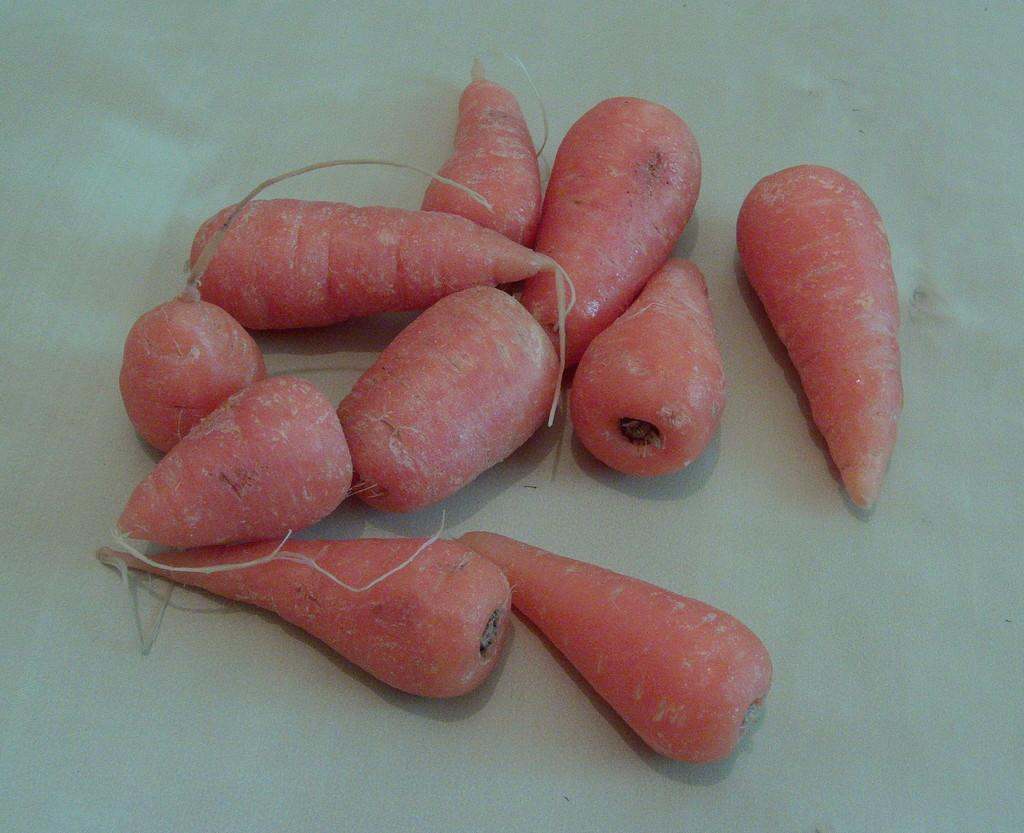What type of vegetable is present in the image? There are carrots in the image. Where are the carrots located in the image? The carrots are located in the center of the image. What type of kite is flying in the image? There is no kite present in the image; it only features carrots. How many planes can be seen flying in the image? There are no planes visible in the image; it only features carrots. 